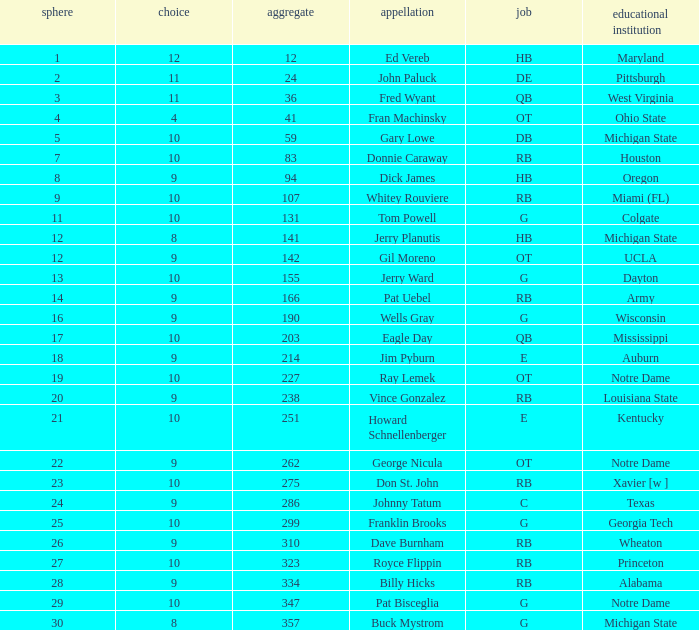What is the total number of overall picks that were after pick 9 and went to Auburn College? 0.0. 